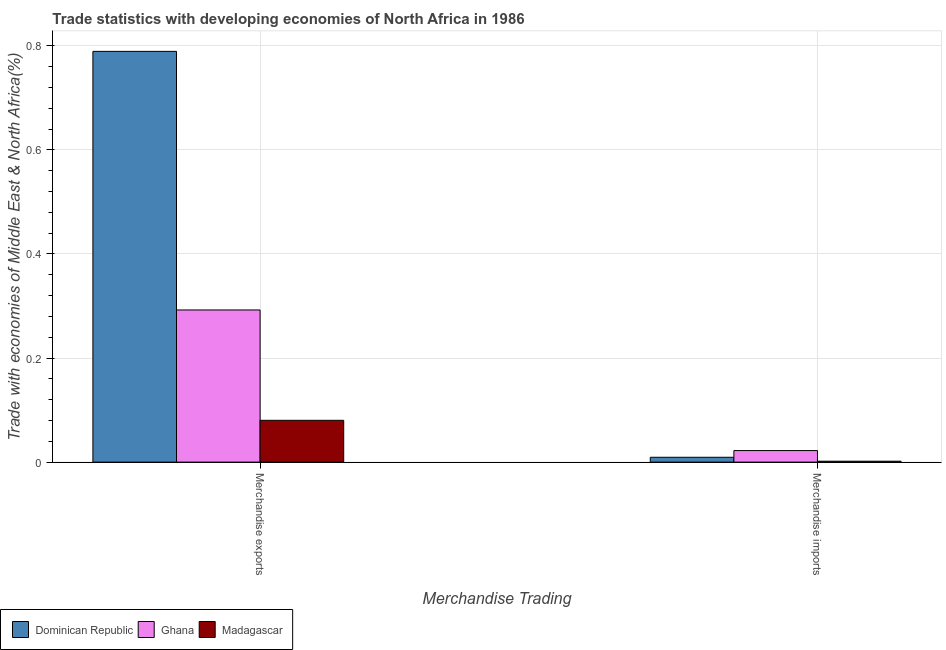How many different coloured bars are there?
Your answer should be compact. 3. Are the number of bars per tick equal to the number of legend labels?
Offer a terse response. Yes. How many bars are there on the 2nd tick from the right?
Your response must be concise. 3. What is the merchandise imports in Madagascar?
Your answer should be compact. 0. Across all countries, what is the maximum merchandise imports?
Provide a short and direct response. 0.02. Across all countries, what is the minimum merchandise imports?
Provide a short and direct response. 0. In which country was the merchandise exports maximum?
Your answer should be compact. Dominican Republic. In which country was the merchandise imports minimum?
Keep it short and to the point. Madagascar. What is the total merchandise imports in the graph?
Keep it short and to the point. 0.03. What is the difference between the merchandise imports in Madagascar and that in Dominican Republic?
Your answer should be compact. -0.01. What is the difference between the merchandise exports in Ghana and the merchandise imports in Dominican Republic?
Provide a short and direct response. 0.28. What is the average merchandise exports per country?
Your answer should be compact. 0.39. What is the difference between the merchandise exports and merchandise imports in Madagascar?
Your response must be concise. 0.08. In how many countries, is the merchandise exports greater than 0.08 %?
Your response must be concise. 3. What is the ratio of the merchandise exports in Dominican Republic to that in Madagascar?
Your response must be concise. 9.82. Is the merchandise imports in Madagascar less than that in Ghana?
Provide a short and direct response. Yes. What does the 3rd bar from the left in Merchandise exports represents?
Ensure brevity in your answer.  Madagascar. What does the 2nd bar from the right in Merchandise imports represents?
Your response must be concise. Ghana. Are all the bars in the graph horizontal?
Your answer should be very brief. No. How many countries are there in the graph?
Give a very brief answer. 3. What is the difference between two consecutive major ticks on the Y-axis?
Ensure brevity in your answer.  0.2. Does the graph contain any zero values?
Keep it short and to the point. No. Does the graph contain grids?
Your answer should be compact. Yes. Where does the legend appear in the graph?
Your response must be concise. Bottom left. How are the legend labels stacked?
Ensure brevity in your answer.  Horizontal. What is the title of the graph?
Keep it short and to the point. Trade statistics with developing economies of North Africa in 1986. What is the label or title of the X-axis?
Ensure brevity in your answer.  Merchandise Trading. What is the label or title of the Y-axis?
Offer a very short reply. Trade with economies of Middle East & North Africa(%). What is the Trade with economies of Middle East & North Africa(%) of Dominican Republic in Merchandise exports?
Make the answer very short. 0.79. What is the Trade with economies of Middle East & North Africa(%) in Ghana in Merchandise exports?
Your answer should be compact. 0.29. What is the Trade with economies of Middle East & North Africa(%) of Madagascar in Merchandise exports?
Provide a succinct answer. 0.08. What is the Trade with economies of Middle East & North Africa(%) of Dominican Republic in Merchandise imports?
Your response must be concise. 0.01. What is the Trade with economies of Middle East & North Africa(%) of Ghana in Merchandise imports?
Provide a succinct answer. 0.02. What is the Trade with economies of Middle East & North Africa(%) of Madagascar in Merchandise imports?
Your answer should be compact. 0. Across all Merchandise Trading, what is the maximum Trade with economies of Middle East & North Africa(%) of Dominican Republic?
Your response must be concise. 0.79. Across all Merchandise Trading, what is the maximum Trade with economies of Middle East & North Africa(%) of Ghana?
Keep it short and to the point. 0.29. Across all Merchandise Trading, what is the maximum Trade with economies of Middle East & North Africa(%) in Madagascar?
Ensure brevity in your answer.  0.08. Across all Merchandise Trading, what is the minimum Trade with economies of Middle East & North Africa(%) of Dominican Republic?
Offer a terse response. 0.01. Across all Merchandise Trading, what is the minimum Trade with economies of Middle East & North Africa(%) of Ghana?
Keep it short and to the point. 0.02. Across all Merchandise Trading, what is the minimum Trade with economies of Middle East & North Africa(%) of Madagascar?
Your answer should be very brief. 0. What is the total Trade with economies of Middle East & North Africa(%) of Dominican Republic in the graph?
Give a very brief answer. 0.8. What is the total Trade with economies of Middle East & North Africa(%) in Ghana in the graph?
Your response must be concise. 0.31. What is the total Trade with economies of Middle East & North Africa(%) in Madagascar in the graph?
Offer a very short reply. 0.08. What is the difference between the Trade with economies of Middle East & North Africa(%) in Dominican Republic in Merchandise exports and that in Merchandise imports?
Make the answer very short. 0.78. What is the difference between the Trade with economies of Middle East & North Africa(%) of Ghana in Merchandise exports and that in Merchandise imports?
Your response must be concise. 0.27. What is the difference between the Trade with economies of Middle East & North Africa(%) of Madagascar in Merchandise exports and that in Merchandise imports?
Your answer should be compact. 0.08. What is the difference between the Trade with economies of Middle East & North Africa(%) of Dominican Republic in Merchandise exports and the Trade with economies of Middle East & North Africa(%) of Ghana in Merchandise imports?
Your answer should be compact. 0.77. What is the difference between the Trade with economies of Middle East & North Africa(%) of Dominican Republic in Merchandise exports and the Trade with economies of Middle East & North Africa(%) of Madagascar in Merchandise imports?
Your response must be concise. 0.79. What is the difference between the Trade with economies of Middle East & North Africa(%) of Ghana in Merchandise exports and the Trade with economies of Middle East & North Africa(%) of Madagascar in Merchandise imports?
Offer a terse response. 0.29. What is the average Trade with economies of Middle East & North Africa(%) in Dominican Republic per Merchandise Trading?
Your answer should be very brief. 0.4. What is the average Trade with economies of Middle East & North Africa(%) in Ghana per Merchandise Trading?
Offer a terse response. 0.16. What is the average Trade with economies of Middle East & North Africa(%) in Madagascar per Merchandise Trading?
Keep it short and to the point. 0.04. What is the difference between the Trade with economies of Middle East & North Africa(%) of Dominican Republic and Trade with economies of Middle East & North Africa(%) of Ghana in Merchandise exports?
Ensure brevity in your answer.  0.5. What is the difference between the Trade with economies of Middle East & North Africa(%) in Dominican Republic and Trade with economies of Middle East & North Africa(%) in Madagascar in Merchandise exports?
Your response must be concise. 0.71. What is the difference between the Trade with economies of Middle East & North Africa(%) of Ghana and Trade with economies of Middle East & North Africa(%) of Madagascar in Merchandise exports?
Provide a short and direct response. 0.21. What is the difference between the Trade with economies of Middle East & North Africa(%) in Dominican Republic and Trade with economies of Middle East & North Africa(%) in Ghana in Merchandise imports?
Make the answer very short. -0.01. What is the difference between the Trade with economies of Middle East & North Africa(%) of Dominican Republic and Trade with economies of Middle East & North Africa(%) of Madagascar in Merchandise imports?
Ensure brevity in your answer.  0.01. What is the difference between the Trade with economies of Middle East & North Africa(%) of Ghana and Trade with economies of Middle East & North Africa(%) of Madagascar in Merchandise imports?
Your answer should be compact. 0.02. What is the ratio of the Trade with economies of Middle East & North Africa(%) of Dominican Republic in Merchandise exports to that in Merchandise imports?
Offer a very short reply. 84.8. What is the ratio of the Trade with economies of Middle East & North Africa(%) in Ghana in Merchandise exports to that in Merchandise imports?
Your answer should be compact. 13.16. What is the ratio of the Trade with economies of Middle East & North Africa(%) of Madagascar in Merchandise exports to that in Merchandise imports?
Make the answer very short. 46.11. What is the difference between the highest and the second highest Trade with economies of Middle East & North Africa(%) in Dominican Republic?
Offer a terse response. 0.78. What is the difference between the highest and the second highest Trade with economies of Middle East & North Africa(%) in Ghana?
Provide a short and direct response. 0.27. What is the difference between the highest and the second highest Trade with economies of Middle East & North Africa(%) of Madagascar?
Provide a short and direct response. 0.08. What is the difference between the highest and the lowest Trade with economies of Middle East & North Africa(%) in Dominican Republic?
Your response must be concise. 0.78. What is the difference between the highest and the lowest Trade with economies of Middle East & North Africa(%) of Ghana?
Your answer should be compact. 0.27. What is the difference between the highest and the lowest Trade with economies of Middle East & North Africa(%) in Madagascar?
Make the answer very short. 0.08. 